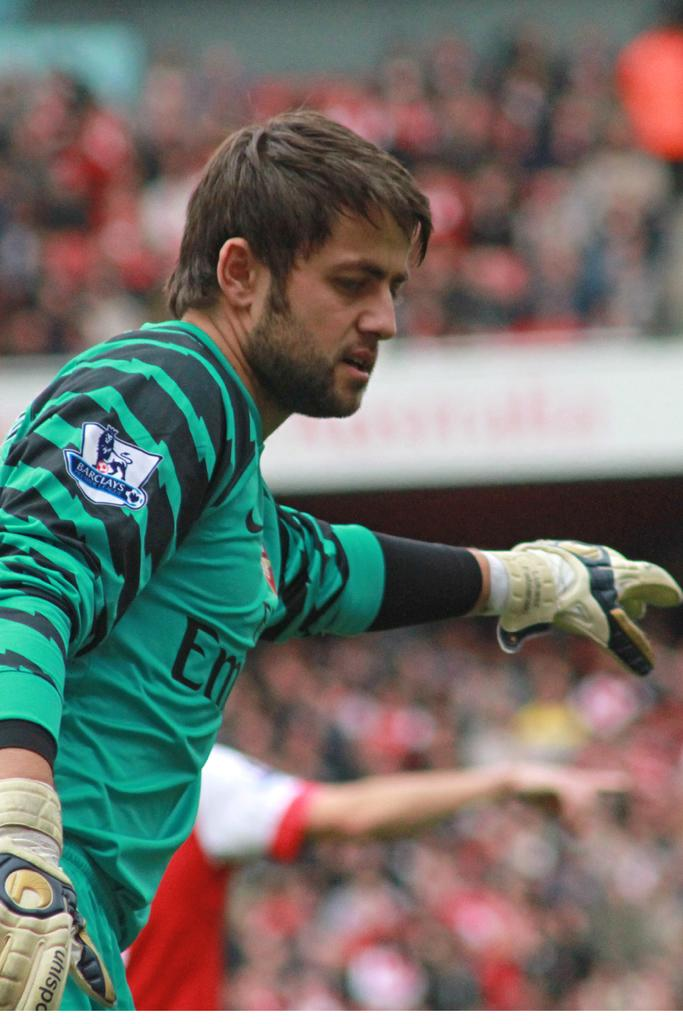What is the position of the man in the image? The man is on the left side of the image. What is the man wearing in the image? The man is wearing a t-shirt. Can you describe the person behind the man? There is another person behind the man, but their appearance is not clear from the image. How would you describe the background of the image? The background of the image appears blurry. What idea does the man have about the bit of loss in the image? There is no indication of any idea, bit, or loss in the image; it only features a man on the left side wearing a t-shirt and a blurry background. 